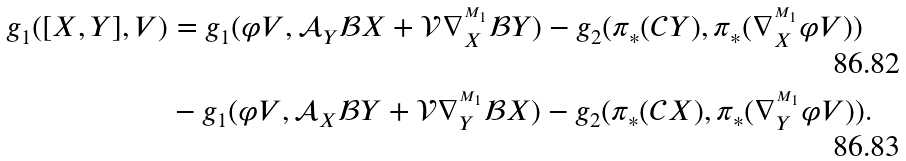<formula> <loc_0><loc_0><loc_500><loc_500>g _ { 1 } ( [ X , Y ] , V ) & = g _ { 1 } ( \varphi V , \mathcal { A } _ { Y } \mathcal { B } X + \mathcal { V } \nabla ^ { ^ { M _ { 1 } } } _ { X } \mathcal { B } Y ) - g _ { 2 } ( \pi _ { \ast } ( \mathcal { C } Y ) , \pi _ { \ast } ( \nabla ^ { ^ { M _ { 1 } } } _ { X } \varphi V ) ) \\ & - g _ { 1 } ( \varphi V , \mathcal { A } _ { X } \mathcal { B } Y + \mathcal { V } \nabla ^ { ^ { M _ { 1 } } } _ { Y } \mathcal { B } X ) - g _ { 2 } ( \pi _ { \ast } ( \mathcal { C } X ) , \pi _ { \ast } ( \nabla ^ { ^ { M _ { 1 } } } _ { Y } \varphi V ) ) .</formula> 